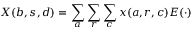<formula> <loc_0><loc_0><loc_500><loc_500>X ( b , s , d ) = \sum _ { a } \sum _ { r } \sum _ { c } x ( a , r , c ) E ( \cdot )</formula> 